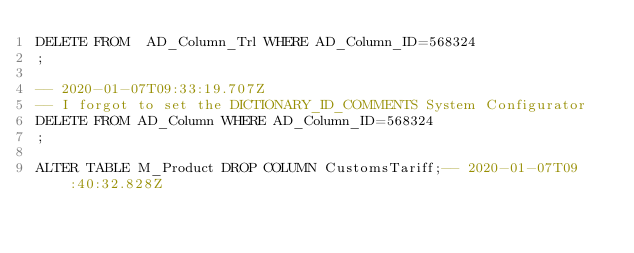<code> <loc_0><loc_0><loc_500><loc_500><_SQL_>DELETE FROM  AD_Column_Trl WHERE AD_Column_ID=568324
;

-- 2020-01-07T09:33:19.707Z
-- I forgot to set the DICTIONARY_ID_COMMENTS System Configurator
DELETE FROM AD_Column WHERE AD_Column_ID=568324
;

ALTER TABLE M_Product DROP COLUMN CustomsTariff;-- 2020-01-07T09:40:32.828Z







</code> 